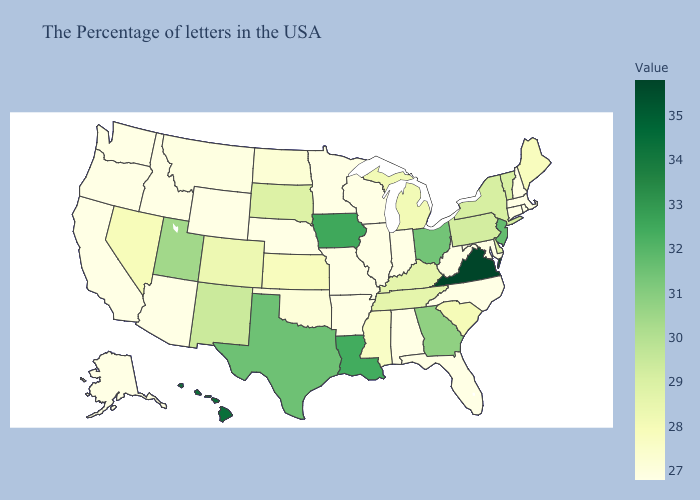Among the states that border Indiana , does Ohio have the lowest value?
Keep it brief. No. Does Oregon have the highest value in the West?
Give a very brief answer. No. Which states have the highest value in the USA?
Write a very short answer. Virginia. Does New Jersey have the highest value in the Northeast?
Give a very brief answer. Yes. 